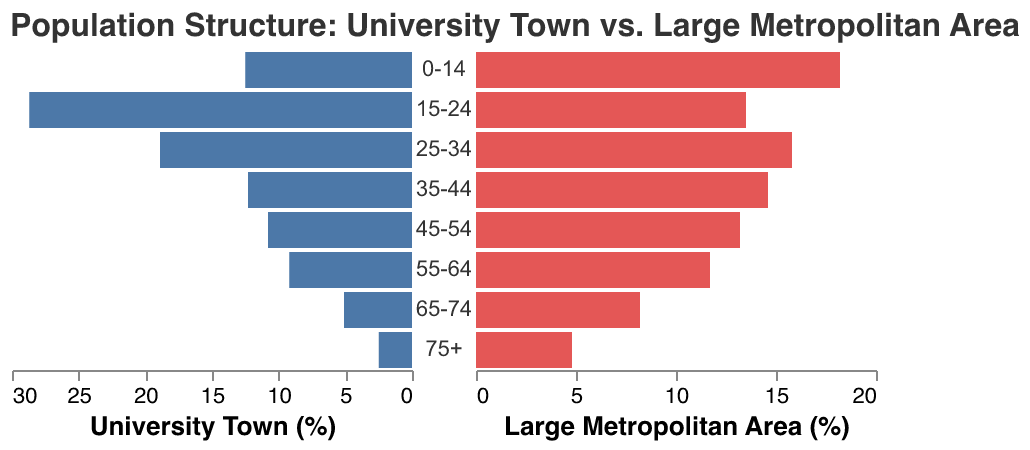What is the percentage of the population in the 25-34 age group in university towns? The figure displays the percentage of the population in various age groups. Locate the 25-34 age group bar for university towns and read the value.
Answer: 18.9% What is the difference in the population percentage of the 75+ age group between large metropolitan areas and university towns? Identify the percentage for the 75+ age group in both large metropolitan areas and university towns, and then calculate the difference: 4.8% - 2.5%
Answer: 2.3% Which age group has the highest population percentage in university towns? Examine the university town section of the figure and find the age group with the tallest (i.e., most negative) bar.
Answer: 15-24 How does the population percentage of the 55-64 age group compare between university towns and large metropolitan areas? Compare the values for the 55-64 age group in both university towns and large metropolitan areas and note any differences.
Answer: University towns: 9.2%, Large metropolitan areas: 11.7% What is the population percentage of the 45-54 age group in large metropolitan areas? Look for the bar corresponding to the 45-54 age group in the large metropolitan areas section and read the value.
Answer: 13.2% Are there more young people (0-14 age group) in university towns or large metropolitan areas? Identify the 0-14 age group percentage in both sections; the higher value indicates where there are more young people.
Answer: Large metropolitan areas Which age group has the smallest population percentage in university towns, and what is that percentage? Locate the smallest bar in the university town section and read the corresponding age group and percentage.
Answer: 75+, 2.5% In which age group do large metropolitan areas have a percentage that is nearly double that of university towns? Compare and identify an age group where the percentage in large metropolitan areas is approximately double that of university towns.
Answer: 0-14 What is the combined population percentage of the 35-44 and 45-54 age groups in large metropolitan areas? Add the percentages for the 35-44 and 45-54 age groups in large metropolitan areas: 14.6% + 13.2%
Answer: 27.8% For the 15-24 age group, what is the difference in percentage points between university towns and large metropolitan areas? Subtract the percentage for large metropolitan areas from university towns for the 15-24 age group: 28.7% - 13.5%
Answer: 15.2% 